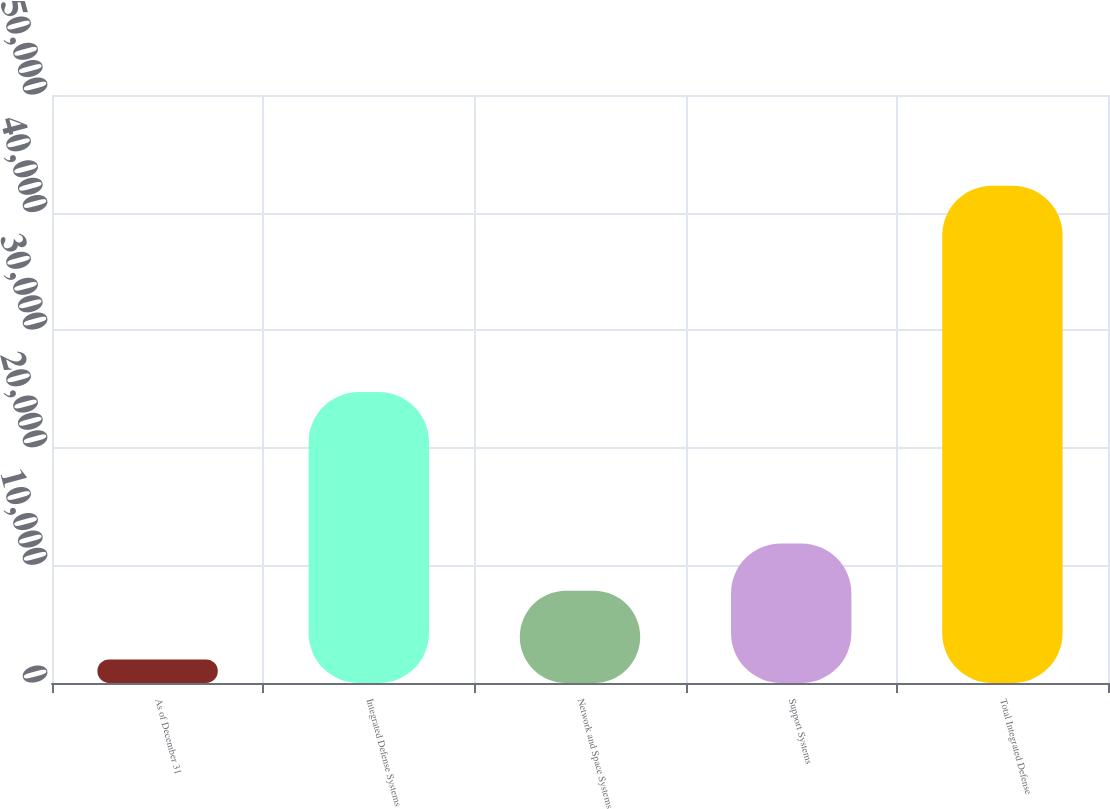Convert chart. <chart><loc_0><loc_0><loc_500><loc_500><bar_chart><fcel>As of December 31<fcel>Integrated Defense Systems<fcel>Network and Space Systems<fcel>Support Systems<fcel>Total Integrated Defense<nl><fcel>2006<fcel>24739<fcel>7838<fcel>11866.5<fcel>42291<nl></chart> 